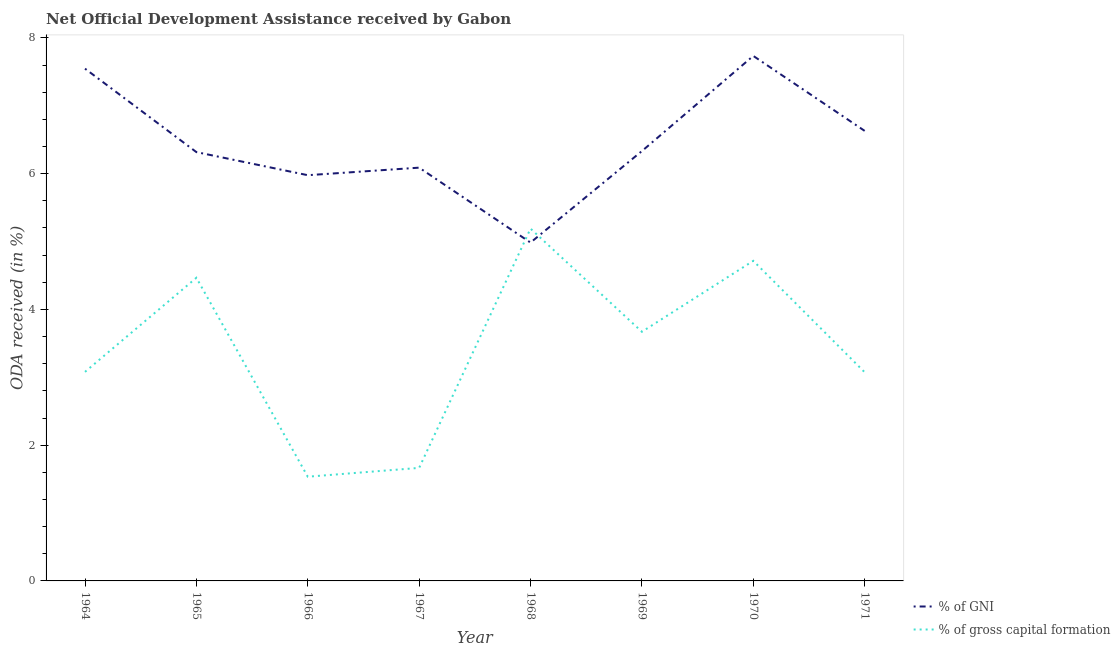How many different coloured lines are there?
Give a very brief answer. 2. Is the number of lines equal to the number of legend labels?
Make the answer very short. Yes. What is the oda received as percentage of gni in 1966?
Provide a succinct answer. 5.98. Across all years, what is the maximum oda received as percentage of gross capital formation?
Your answer should be compact. 5.19. Across all years, what is the minimum oda received as percentage of gni?
Give a very brief answer. 4.99. In which year was the oda received as percentage of gross capital formation maximum?
Ensure brevity in your answer.  1968. In which year was the oda received as percentage of gross capital formation minimum?
Keep it short and to the point. 1966. What is the total oda received as percentage of gross capital formation in the graph?
Make the answer very short. 27.4. What is the difference between the oda received as percentage of gross capital formation in 1967 and that in 1971?
Offer a very short reply. -1.41. What is the difference between the oda received as percentage of gni in 1964 and the oda received as percentage of gross capital formation in 1967?
Provide a succinct answer. 5.88. What is the average oda received as percentage of gross capital formation per year?
Make the answer very short. 3.43. In the year 1965, what is the difference between the oda received as percentage of gross capital formation and oda received as percentage of gni?
Ensure brevity in your answer.  -1.85. What is the ratio of the oda received as percentage of gross capital formation in 1964 to that in 1968?
Your response must be concise. 0.59. What is the difference between the highest and the second highest oda received as percentage of gni?
Make the answer very short. 0.19. What is the difference between the highest and the lowest oda received as percentage of gni?
Give a very brief answer. 2.75. In how many years, is the oda received as percentage of gross capital formation greater than the average oda received as percentage of gross capital formation taken over all years?
Your response must be concise. 4. Is the oda received as percentage of gni strictly less than the oda received as percentage of gross capital formation over the years?
Provide a short and direct response. No. How many lines are there?
Provide a succinct answer. 2. How many years are there in the graph?
Your answer should be very brief. 8. Does the graph contain grids?
Provide a succinct answer. No. How many legend labels are there?
Give a very brief answer. 2. How are the legend labels stacked?
Ensure brevity in your answer.  Vertical. What is the title of the graph?
Offer a very short reply. Net Official Development Assistance received by Gabon. What is the label or title of the X-axis?
Your response must be concise. Year. What is the label or title of the Y-axis?
Offer a terse response. ODA received (in %). What is the ODA received (in %) in % of GNI in 1964?
Ensure brevity in your answer.  7.55. What is the ODA received (in %) of % of gross capital formation in 1964?
Ensure brevity in your answer.  3.08. What is the ODA received (in %) of % of GNI in 1965?
Offer a terse response. 6.32. What is the ODA received (in %) of % of gross capital formation in 1965?
Provide a short and direct response. 4.47. What is the ODA received (in %) of % of GNI in 1966?
Keep it short and to the point. 5.98. What is the ODA received (in %) of % of gross capital formation in 1966?
Your answer should be very brief. 1.54. What is the ODA received (in %) in % of GNI in 1967?
Your answer should be very brief. 6.09. What is the ODA received (in %) in % of gross capital formation in 1967?
Provide a succinct answer. 1.67. What is the ODA received (in %) in % of GNI in 1968?
Keep it short and to the point. 4.99. What is the ODA received (in %) of % of gross capital formation in 1968?
Provide a succinct answer. 5.19. What is the ODA received (in %) of % of GNI in 1969?
Your answer should be very brief. 6.33. What is the ODA received (in %) in % of gross capital formation in 1969?
Your answer should be compact. 3.67. What is the ODA received (in %) of % of GNI in 1970?
Give a very brief answer. 7.74. What is the ODA received (in %) of % of gross capital formation in 1970?
Provide a succinct answer. 4.72. What is the ODA received (in %) of % of GNI in 1971?
Make the answer very short. 6.63. What is the ODA received (in %) in % of gross capital formation in 1971?
Your answer should be very brief. 3.07. Across all years, what is the maximum ODA received (in %) of % of GNI?
Make the answer very short. 7.74. Across all years, what is the maximum ODA received (in %) of % of gross capital formation?
Keep it short and to the point. 5.19. Across all years, what is the minimum ODA received (in %) of % of GNI?
Your answer should be very brief. 4.99. Across all years, what is the minimum ODA received (in %) in % of gross capital formation?
Keep it short and to the point. 1.54. What is the total ODA received (in %) in % of GNI in the graph?
Offer a terse response. 51.62. What is the total ODA received (in %) in % of gross capital formation in the graph?
Keep it short and to the point. 27.4. What is the difference between the ODA received (in %) in % of GNI in 1964 and that in 1965?
Keep it short and to the point. 1.23. What is the difference between the ODA received (in %) in % of gross capital formation in 1964 and that in 1965?
Your response must be concise. -1.39. What is the difference between the ODA received (in %) in % of GNI in 1964 and that in 1966?
Make the answer very short. 1.57. What is the difference between the ODA received (in %) in % of gross capital formation in 1964 and that in 1966?
Make the answer very short. 1.54. What is the difference between the ODA received (in %) of % of GNI in 1964 and that in 1967?
Provide a short and direct response. 1.46. What is the difference between the ODA received (in %) of % of gross capital formation in 1964 and that in 1967?
Provide a short and direct response. 1.41. What is the difference between the ODA received (in %) of % of GNI in 1964 and that in 1968?
Your answer should be compact. 2.56. What is the difference between the ODA received (in %) in % of gross capital formation in 1964 and that in 1968?
Keep it short and to the point. -2.11. What is the difference between the ODA received (in %) of % of GNI in 1964 and that in 1969?
Your response must be concise. 1.21. What is the difference between the ODA received (in %) in % of gross capital formation in 1964 and that in 1969?
Provide a short and direct response. -0.59. What is the difference between the ODA received (in %) in % of GNI in 1964 and that in 1970?
Give a very brief answer. -0.19. What is the difference between the ODA received (in %) of % of gross capital formation in 1964 and that in 1970?
Give a very brief answer. -1.64. What is the difference between the ODA received (in %) of % of GNI in 1964 and that in 1971?
Make the answer very short. 0.92. What is the difference between the ODA received (in %) of % of gross capital formation in 1964 and that in 1971?
Make the answer very short. 0.01. What is the difference between the ODA received (in %) of % of GNI in 1965 and that in 1966?
Ensure brevity in your answer.  0.34. What is the difference between the ODA received (in %) of % of gross capital formation in 1965 and that in 1966?
Ensure brevity in your answer.  2.93. What is the difference between the ODA received (in %) in % of GNI in 1965 and that in 1967?
Keep it short and to the point. 0.23. What is the difference between the ODA received (in %) of % of gross capital formation in 1965 and that in 1967?
Keep it short and to the point. 2.8. What is the difference between the ODA received (in %) of % of GNI in 1965 and that in 1968?
Your response must be concise. 1.33. What is the difference between the ODA received (in %) in % of gross capital formation in 1965 and that in 1968?
Provide a succinct answer. -0.72. What is the difference between the ODA received (in %) in % of GNI in 1965 and that in 1969?
Your response must be concise. -0.01. What is the difference between the ODA received (in %) of % of gross capital formation in 1965 and that in 1969?
Provide a short and direct response. 0.8. What is the difference between the ODA received (in %) of % of GNI in 1965 and that in 1970?
Your response must be concise. -1.42. What is the difference between the ODA received (in %) in % of gross capital formation in 1965 and that in 1970?
Give a very brief answer. -0.25. What is the difference between the ODA received (in %) of % of GNI in 1965 and that in 1971?
Keep it short and to the point. -0.31. What is the difference between the ODA received (in %) in % of gross capital formation in 1965 and that in 1971?
Provide a succinct answer. 1.39. What is the difference between the ODA received (in %) of % of GNI in 1966 and that in 1967?
Offer a very short reply. -0.11. What is the difference between the ODA received (in %) in % of gross capital formation in 1966 and that in 1967?
Make the answer very short. -0.13. What is the difference between the ODA received (in %) of % of gross capital formation in 1966 and that in 1968?
Provide a succinct answer. -3.66. What is the difference between the ODA received (in %) in % of GNI in 1966 and that in 1969?
Your response must be concise. -0.36. What is the difference between the ODA received (in %) of % of gross capital formation in 1966 and that in 1969?
Make the answer very short. -2.14. What is the difference between the ODA received (in %) in % of GNI in 1966 and that in 1970?
Your answer should be very brief. -1.76. What is the difference between the ODA received (in %) of % of gross capital formation in 1966 and that in 1970?
Keep it short and to the point. -3.18. What is the difference between the ODA received (in %) of % of GNI in 1966 and that in 1971?
Your answer should be very brief. -0.65. What is the difference between the ODA received (in %) in % of gross capital formation in 1966 and that in 1971?
Provide a short and direct response. -1.54. What is the difference between the ODA received (in %) in % of GNI in 1967 and that in 1968?
Offer a terse response. 1.1. What is the difference between the ODA received (in %) of % of gross capital formation in 1967 and that in 1968?
Your response must be concise. -3.53. What is the difference between the ODA received (in %) in % of GNI in 1967 and that in 1969?
Your answer should be compact. -0.24. What is the difference between the ODA received (in %) in % of gross capital formation in 1967 and that in 1969?
Keep it short and to the point. -2.01. What is the difference between the ODA received (in %) of % of GNI in 1967 and that in 1970?
Provide a short and direct response. -1.65. What is the difference between the ODA received (in %) in % of gross capital formation in 1967 and that in 1970?
Provide a short and direct response. -3.05. What is the difference between the ODA received (in %) of % of GNI in 1967 and that in 1971?
Provide a succinct answer. -0.54. What is the difference between the ODA received (in %) of % of gross capital formation in 1967 and that in 1971?
Keep it short and to the point. -1.41. What is the difference between the ODA received (in %) in % of GNI in 1968 and that in 1969?
Your answer should be very brief. -1.35. What is the difference between the ODA received (in %) in % of gross capital formation in 1968 and that in 1969?
Make the answer very short. 1.52. What is the difference between the ODA received (in %) in % of GNI in 1968 and that in 1970?
Ensure brevity in your answer.  -2.75. What is the difference between the ODA received (in %) in % of gross capital formation in 1968 and that in 1970?
Offer a terse response. 0.47. What is the difference between the ODA received (in %) of % of GNI in 1968 and that in 1971?
Provide a succinct answer. -1.65. What is the difference between the ODA received (in %) in % of gross capital formation in 1968 and that in 1971?
Offer a very short reply. 2.12. What is the difference between the ODA received (in %) of % of GNI in 1969 and that in 1970?
Provide a short and direct response. -1.4. What is the difference between the ODA received (in %) in % of gross capital formation in 1969 and that in 1970?
Your answer should be compact. -1.04. What is the difference between the ODA received (in %) of % of GNI in 1969 and that in 1971?
Your answer should be compact. -0.3. What is the difference between the ODA received (in %) of % of gross capital formation in 1969 and that in 1971?
Your answer should be very brief. 0.6. What is the difference between the ODA received (in %) in % of GNI in 1970 and that in 1971?
Keep it short and to the point. 1.1. What is the difference between the ODA received (in %) in % of gross capital formation in 1970 and that in 1971?
Offer a very short reply. 1.64. What is the difference between the ODA received (in %) of % of GNI in 1964 and the ODA received (in %) of % of gross capital formation in 1965?
Give a very brief answer. 3.08. What is the difference between the ODA received (in %) of % of GNI in 1964 and the ODA received (in %) of % of gross capital formation in 1966?
Keep it short and to the point. 6.01. What is the difference between the ODA received (in %) in % of GNI in 1964 and the ODA received (in %) in % of gross capital formation in 1967?
Give a very brief answer. 5.88. What is the difference between the ODA received (in %) in % of GNI in 1964 and the ODA received (in %) in % of gross capital formation in 1968?
Keep it short and to the point. 2.36. What is the difference between the ODA received (in %) of % of GNI in 1964 and the ODA received (in %) of % of gross capital formation in 1969?
Ensure brevity in your answer.  3.88. What is the difference between the ODA received (in %) of % of GNI in 1964 and the ODA received (in %) of % of gross capital formation in 1970?
Give a very brief answer. 2.83. What is the difference between the ODA received (in %) of % of GNI in 1964 and the ODA received (in %) of % of gross capital formation in 1971?
Make the answer very short. 4.47. What is the difference between the ODA received (in %) of % of GNI in 1965 and the ODA received (in %) of % of gross capital formation in 1966?
Make the answer very short. 4.78. What is the difference between the ODA received (in %) of % of GNI in 1965 and the ODA received (in %) of % of gross capital formation in 1967?
Your response must be concise. 4.65. What is the difference between the ODA received (in %) in % of GNI in 1965 and the ODA received (in %) in % of gross capital formation in 1968?
Your answer should be very brief. 1.13. What is the difference between the ODA received (in %) in % of GNI in 1965 and the ODA received (in %) in % of gross capital formation in 1969?
Give a very brief answer. 2.65. What is the difference between the ODA received (in %) of % of GNI in 1965 and the ODA received (in %) of % of gross capital formation in 1970?
Your answer should be compact. 1.6. What is the difference between the ODA received (in %) of % of GNI in 1965 and the ODA received (in %) of % of gross capital formation in 1971?
Your answer should be compact. 3.24. What is the difference between the ODA received (in %) in % of GNI in 1966 and the ODA received (in %) in % of gross capital formation in 1967?
Give a very brief answer. 4.31. What is the difference between the ODA received (in %) in % of GNI in 1966 and the ODA received (in %) in % of gross capital formation in 1968?
Keep it short and to the point. 0.79. What is the difference between the ODA received (in %) in % of GNI in 1966 and the ODA received (in %) in % of gross capital formation in 1969?
Your answer should be very brief. 2.31. What is the difference between the ODA received (in %) of % of GNI in 1966 and the ODA received (in %) of % of gross capital formation in 1970?
Offer a very short reply. 1.26. What is the difference between the ODA received (in %) in % of GNI in 1966 and the ODA received (in %) in % of gross capital formation in 1971?
Give a very brief answer. 2.9. What is the difference between the ODA received (in %) of % of GNI in 1967 and the ODA received (in %) of % of gross capital formation in 1968?
Provide a short and direct response. 0.9. What is the difference between the ODA received (in %) of % of GNI in 1967 and the ODA received (in %) of % of gross capital formation in 1969?
Keep it short and to the point. 2.42. What is the difference between the ODA received (in %) in % of GNI in 1967 and the ODA received (in %) in % of gross capital formation in 1970?
Make the answer very short. 1.37. What is the difference between the ODA received (in %) in % of GNI in 1967 and the ODA received (in %) in % of gross capital formation in 1971?
Offer a terse response. 3.01. What is the difference between the ODA received (in %) of % of GNI in 1968 and the ODA received (in %) of % of gross capital formation in 1969?
Offer a very short reply. 1.31. What is the difference between the ODA received (in %) of % of GNI in 1968 and the ODA received (in %) of % of gross capital formation in 1970?
Provide a short and direct response. 0.27. What is the difference between the ODA received (in %) of % of GNI in 1968 and the ODA received (in %) of % of gross capital formation in 1971?
Your answer should be very brief. 1.91. What is the difference between the ODA received (in %) of % of GNI in 1969 and the ODA received (in %) of % of gross capital formation in 1970?
Ensure brevity in your answer.  1.62. What is the difference between the ODA received (in %) in % of GNI in 1969 and the ODA received (in %) in % of gross capital formation in 1971?
Provide a short and direct response. 3.26. What is the difference between the ODA received (in %) in % of GNI in 1970 and the ODA received (in %) in % of gross capital formation in 1971?
Offer a terse response. 4.66. What is the average ODA received (in %) of % of GNI per year?
Offer a very short reply. 6.45. What is the average ODA received (in %) of % of gross capital formation per year?
Make the answer very short. 3.43. In the year 1964, what is the difference between the ODA received (in %) of % of GNI and ODA received (in %) of % of gross capital formation?
Make the answer very short. 4.47. In the year 1965, what is the difference between the ODA received (in %) of % of GNI and ODA received (in %) of % of gross capital formation?
Your answer should be compact. 1.85. In the year 1966, what is the difference between the ODA received (in %) in % of GNI and ODA received (in %) in % of gross capital formation?
Your answer should be very brief. 4.44. In the year 1967, what is the difference between the ODA received (in %) of % of GNI and ODA received (in %) of % of gross capital formation?
Offer a terse response. 4.42. In the year 1968, what is the difference between the ODA received (in %) of % of GNI and ODA received (in %) of % of gross capital formation?
Keep it short and to the point. -0.21. In the year 1969, what is the difference between the ODA received (in %) of % of GNI and ODA received (in %) of % of gross capital formation?
Provide a short and direct response. 2.66. In the year 1970, what is the difference between the ODA received (in %) of % of GNI and ODA received (in %) of % of gross capital formation?
Make the answer very short. 3.02. In the year 1971, what is the difference between the ODA received (in %) in % of GNI and ODA received (in %) in % of gross capital formation?
Make the answer very short. 3.56. What is the ratio of the ODA received (in %) in % of GNI in 1964 to that in 1965?
Give a very brief answer. 1.19. What is the ratio of the ODA received (in %) of % of gross capital formation in 1964 to that in 1965?
Your answer should be compact. 0.69. What is the ratio of the ODA received (in %) of % of GNI in 1964 to that in 1966?
Keep it short and to the point. 1.26. What is the ratio of the ODA received (in %) of % of gross capital formation in 1964 to that in 1966?
Offer a terse response. 2.01. What is the ratio of the ODA received (in %) in % of GNI in 1964 to that in 1967?
Make the answer very short. 1.24. What is the ratio of the ODA received (in %) in % of gross capital formation in 1964 to that in 1967?
Your answer should be very brief. 1.85. What is the ratio of the ODA received (in %) in % of GNI in 1964 to that in 1968?
Keep it short and to the point. 1.51. What is the ratio of the ODA received (in %) in % of gross capital formation in 1964 to that in 1968?
Make the answer very short. 0.59. What is the ratio of the ODA received (in %) in % of GNI in 1964 to that in 1969?
Offer a very short reply. 1.19. What is the ratio of the ODA received (in %) in % of gross capital formation in 1964 to that in 1969?
Ensure brevity in your answer.  0.84. What is the ratio of the ODA received (in %) of % of GNI in 1964 to that in 1970?
Give a very brief answer. 0.98. What is the ratio of the ODA received (in %) of % of gross capital formation in 1964 to that in 1970?
Give a very brief answer. 0.65. What is the ratio of the ODA received (in %) in % of GNI in 1964 to that in 1971?
Keep it short and to the point. 1.14. What is the ratio of the ODA received (in %) in % of gross capital formation in 1964 to that in 1971?
Your answer should be very brief. 1. What is the ratio of the ODA received (in %) of % of GNI in 1965 to that in 1966?
Provide a short and direct response. 1.06. What is the ratio of the ODA received (in %) in % of gross capital formation in 1965 to that in 1966?
Your answer should be very brief. 2.91. What is the ratio of the ODA received (in %) in % of GNI in 1965 to that in 1967?
Your answer should be compact. 1.04. What is the ratio of the ODA received (in %) of % of gross capital formation in 1965 to that in 1967?
Offer a very short reply. 2.68. What is the ratio of the ODA received (in %) of % of GNI in 1965 to that in 1968?
Provide a short and direct response. 1.27. What is the ratio of the ODA received (in %) in % of gross capital formation in 1965 to that in 1968?
Ensure brevity in your answer.  0.86. What is the ratio of the ODA received (in %) in % of gross capital formation in 1965 to that in 1969?
Your answer should be very brief. 1.22. What is the ratio of the ODA received (in %) of % of GNI in 1965 to that in 1970?
Offer a very short reply. 0.82. What is the ratio of the ODA received (in %) of % of gross capital formation in 1965 to that in 1970?
Provide a succinct answer. 0.95. What is the ratio of the ODA received (in %) in % of GNI in 1965 to that in 1971?
Keep it short and to the point. 0.95. What is the ratio of the ODA received (in %) in % of gross capital formation in 1965 to that in 1971?
Your answer should be compact. 1.45. What is the ratio of the ODA received (in %) of % of GNI in 1966 to that in 1967?
Keep it short and to the point. 0.98. What is the ratio of the ODA received (in %) of % of gross capital formation in 1966 to that in 1967?
Provide a short and direct response. 0.92. What is the ratio of the ODA received (in %) of % of GNI in 1966 to that in 1968?
Offer a very short reply. 1.2. What is the ratio of the ODA received (in %) in % of gross capital formation in 1966 to that in 1968?
Give a very brief answer. 0.3. What is the ratio of the ODA received (in %) of % of GNI in 1966 to that in 1969?
Provide a succinct answer. 0.94. What is the ratio of the ODA received (in %) in % of gross capital formation in 1966 to that in 1969?
Your answer should be very brief. 0.42. What is the ratio of the ODA received (in %) in % of GNI in 1966 to that in 1970?
Give a very brief answer. 0.77. What is the ratio of the ODA received (in %) in % of gross capital formation in 1966 to that in 1970?
Offer a very short reply. 0.33. What is the ratio of the ODA received (in %) of % of GNI in 1966 to that in 1971?
Keep it short and to the point. 0.9. What is the ratio of the ODA received (in %) of % of gross capital formation in 1966 to that in 1971?
Make the answer very short. 0.5. What is the ratio of the ODA received (in %) in % of GNI in 1967 to that in 1968?
Offer a very short reply. 1.22. What is the ratio of the ODA received (in %) in % of gross capital formation in 1967 to that in 1968?
Provide a succinct answer. 0.32. What is the ratio of the ODA received (in %) in % of GNI in 1967 to that in 1969?
Your answer should be very brief. 0.96. What is the ratio of the ODA received (in %) of % of gross capital formation in 1967 to that in 1969?
Give a very brief answer. 0.45. What is the ratio of the ODA received (in %) of % of GNI in 1967 to that in 1970?
Your response must be concise. 0.79. What is the ratio of the ODA received (in %) of % of gross capital formation in 1967 to that in 1970?
Provide a short and direct response. 0.35. What is the ratio of the ODA received (in %) in % of GNI in 1967 to that in 1971?
Your response must be concise. 0.92. What is the ratio of the ODA received (in %) in % of gross capital formation in 1967 to that in 1971?
Provide a short and direct response. 0.54. What is the ratio of the ODA received (in %) in % of GNI in 1968 to that in 1969?
Give a very brief answer. 0.79. What is the ratio of the ODA received (in %) in % of gross capital formation in 1968 to that in 1969?
Provide a succinct answer. 1.41. What is the ratio of the ODA received (in %) in % of GNI in 1968 to that in 1970?
Provide a succinct answer. 0.64. What is the ratio of the ODA received (in %) in % of gross capital formation in 1968 to that in 1970?
Give a very brief answer. 1.1. What is the ratio of the ODA received (in %) in % of GNI in 1968 to that in 1971?
Ensure brevity in your answer.  0.75. What is the ratio of the ODA received (in %) of % of gross capital formation in 1968 to that in 1971?
Provide a succinct answer. 1.69. What is the ratio of the ODA received (in %) of % of GNI in 1969 to that in 1970?
Ensure brevity in your answer.  0.82. What is the ratio of the ODA received (in %) in % of gross capital formation in 1969 to that in 1970?
Offer a very short reply. 0.78. What is the ratio of the ODA received (in %) in % of GNI in 1969 to that in 1971?
Keep it short and to the point. 0.96. What is the ratio of the ODA received (in %) of % of gross capital formation in 1969 to that in 1971?
Offer a terse response. 1.19. What is the ratio of the ODA received (in %) of % of GNI in 1970 to that in 1971?
Offer a terse response. 1.17. What is the ratio of the ODA received (in %) of % of gross capital formation in 1970 to that in 1971?
Your answer should be very brief. 1.53. What is the difference between the highest and the second highest ODA received (in %) of % of GNI?
Your answer should be compact. 0.19. What is the difference between the highest and the second highest ODA received (in %) in % of gross capital formation?
Make the answer very short. 0.47. What is the difference between the highest and the lowest ODA received (in %) in % of GNI?
Keep it short and to the point. 2.75. What is the difference between the highest and the lowest ODA received (in %) in % of gross capital formation?
Offer a very short reply. 3.66. 